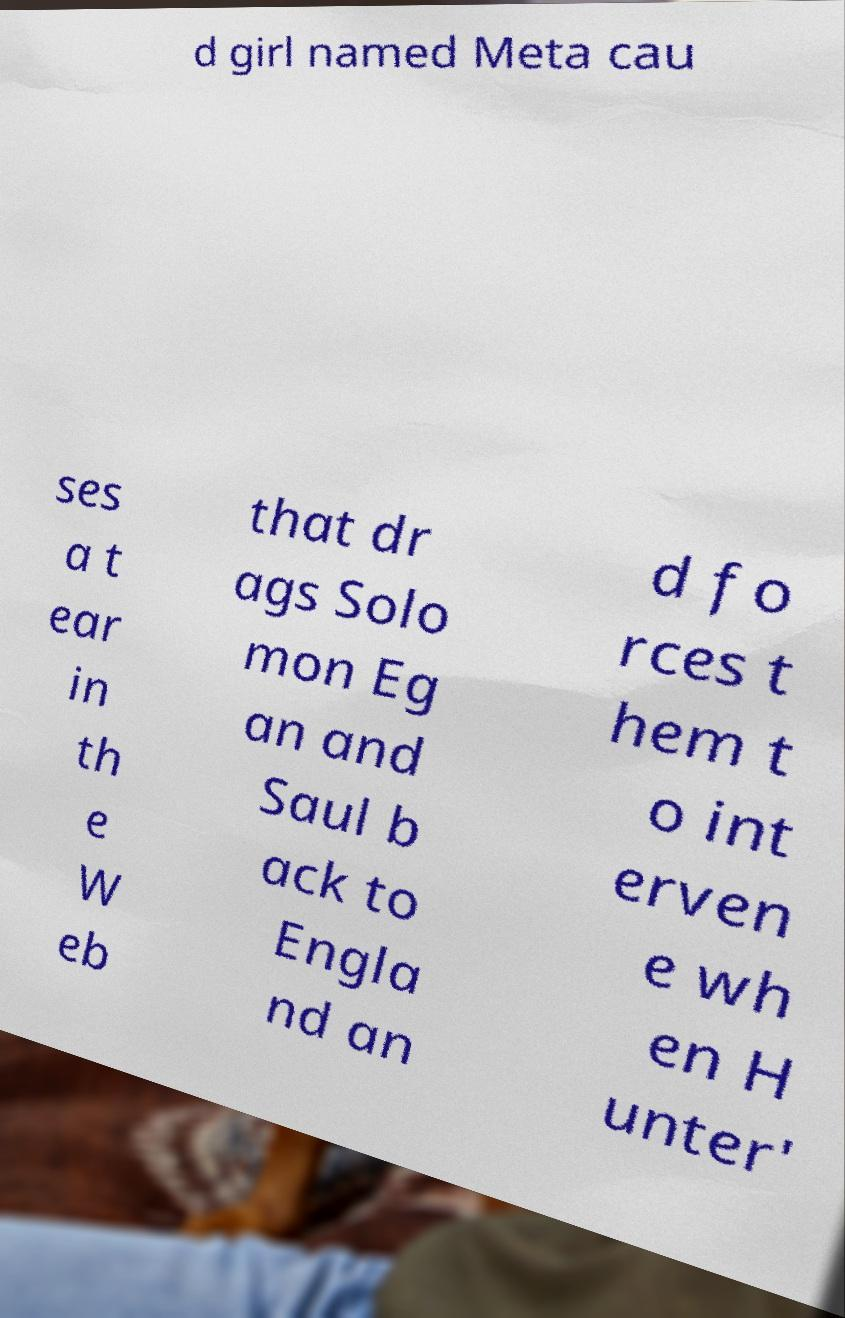Please identify and transcribe the text found in this image. d girl named Meta cau ses a t ear in th e W eb that dr ags Solo mon Eg an and Saul b ack to Engla nd an d fo rces t hem t o int erven e wh en H unter' 